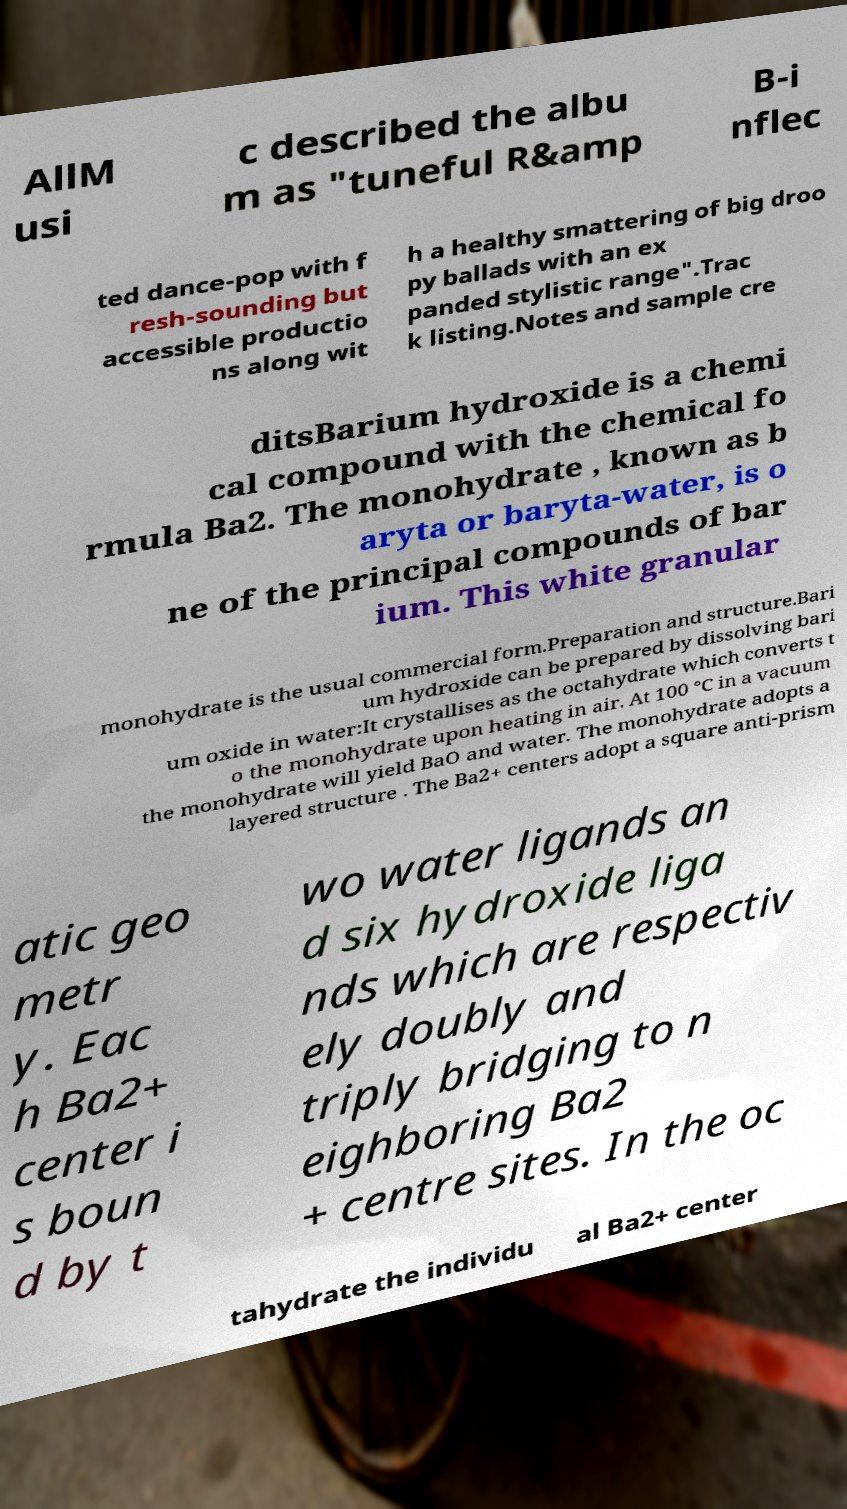Can you read and provide the text displayed in the image?This photo seems to have some interesting text. Can you extract and type it out for me? AllM usi c described the albu m as "tuneful R&amp B-i nflec ted dance-pop with f resh-sounding but accessible productio ns along wit h a healthy smattering of big droo py ballads with an ex panded stylistic range".Trac k listing.Notes and sample cre ditsBarium hydroxide is a chemi cal compound with the chemical fo rmula Ba2. The monohydrate , known as b aryta or baryta-water, is o ne of the principal compounds of bar ium. This white granular monohydrate is the usual commercial form.Preparation and structure.Bari um hydroxide can be prepared by dissolving bari um oxide in water:It crystallises as the octahydrate which converts t o the monohydrate upon heating in air. At 100 °C in a vacuum the monohydrate will yield BaO and water. The monohydrate adopts a layered structure . The Ba2+ centers adopt a square anti-prism atic geo metr y. Eac h Ba2+ center i s boun d by t wo water ligands an d six hydroxide liga nds which are respectiv ely doubly and triply bridging to n eighboring Ba2 + centre sites. In the oc tahydrate the individu al Ba2+ center 